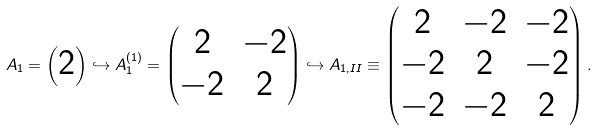<formula> <loc_0><loc_0><loc_500><loc_500>A _ { 1 } = \begin{pmatrix} 2 \end{pmatrix} \hookrightarrow A _ { 1 } ^ { ( 1 ) } = \begin{pmatrix} 2 & - 2 \\ - 2 & 2 \end{pmatrix} \hookrightarrow A _ { 1 , I I } \equiv \begin{pmatrix} 2 & - 2 & - 2 \\ - 2 & 2 & - 2 \\ - 2 & - 2 & 2 \end{pmatrix} .</formula> 